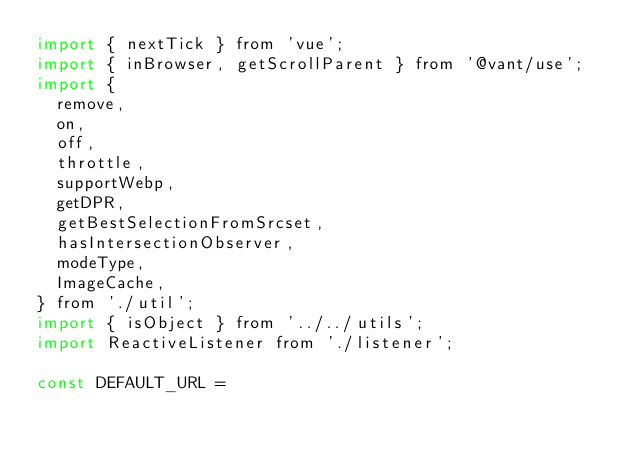<code> <loc_0><loc_0><loc_500><loc_500><_JavaScript_>import { nextTick } from 'vue';
import { inBrowser, getScrollParent } from '@vant/use';
import {
  remove,
  on,
  off,
  throttle,
  supportWebp,
  getDPR,
  getBestSelectionFromSrcset,
  hasIntersectionObserver,
  modeType,
  ImageCache,
} from './util';
import { isObject } from '../../utils';
import ReactiveListener from './listener';

const DEFAULT_URL =</code> 